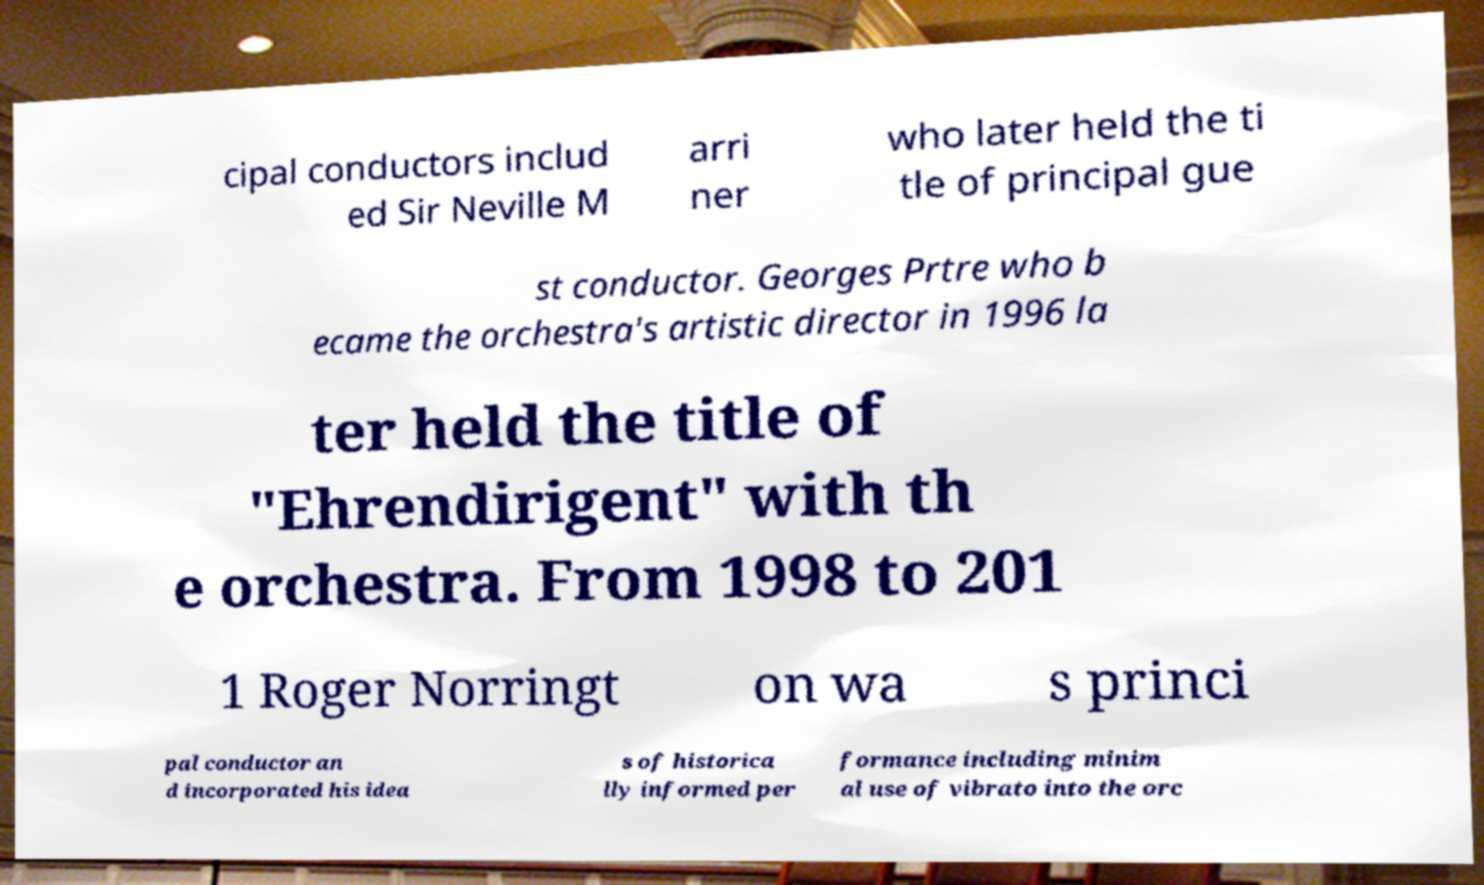Please read and relay the text visible in this image. What does it say? cipal conductors includ ed Sir Neville M arri ner who later held the ti tle of principal gue st conductor. Georges Prtre who b ecame the orchestra's artistic director in 1996 la ter held the title of "Ehrendirigent" with th e orchestra. From 1998 to 201 1 Roger Norringt on wa s princi pal conductor an d incorporated his idea s of historica lly informed per formance including minim al use of vibrato into the orc 